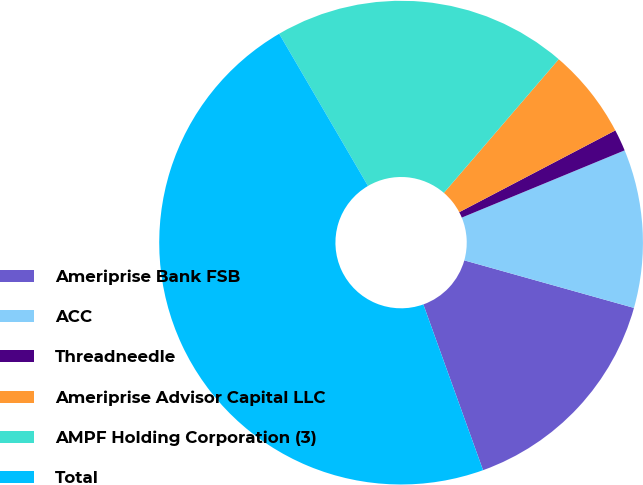Convert chart. <chart><loc_0><loc_0><loc_500><loc_500><pie_chart><fcel>Ameriprise Bank FSB<fcel>ACC<fcel>Threadneedle<fcel>Ameriprise Advisor Capital LLC<fcel>AMPF Holding Corporation (3)<fcel>Total<nl><fcel>15.15%<fcel>10.58%<fcel>1.45%<fcel>6.02%<fcel>19.71%<fcel>47.1%<nl></chart> 